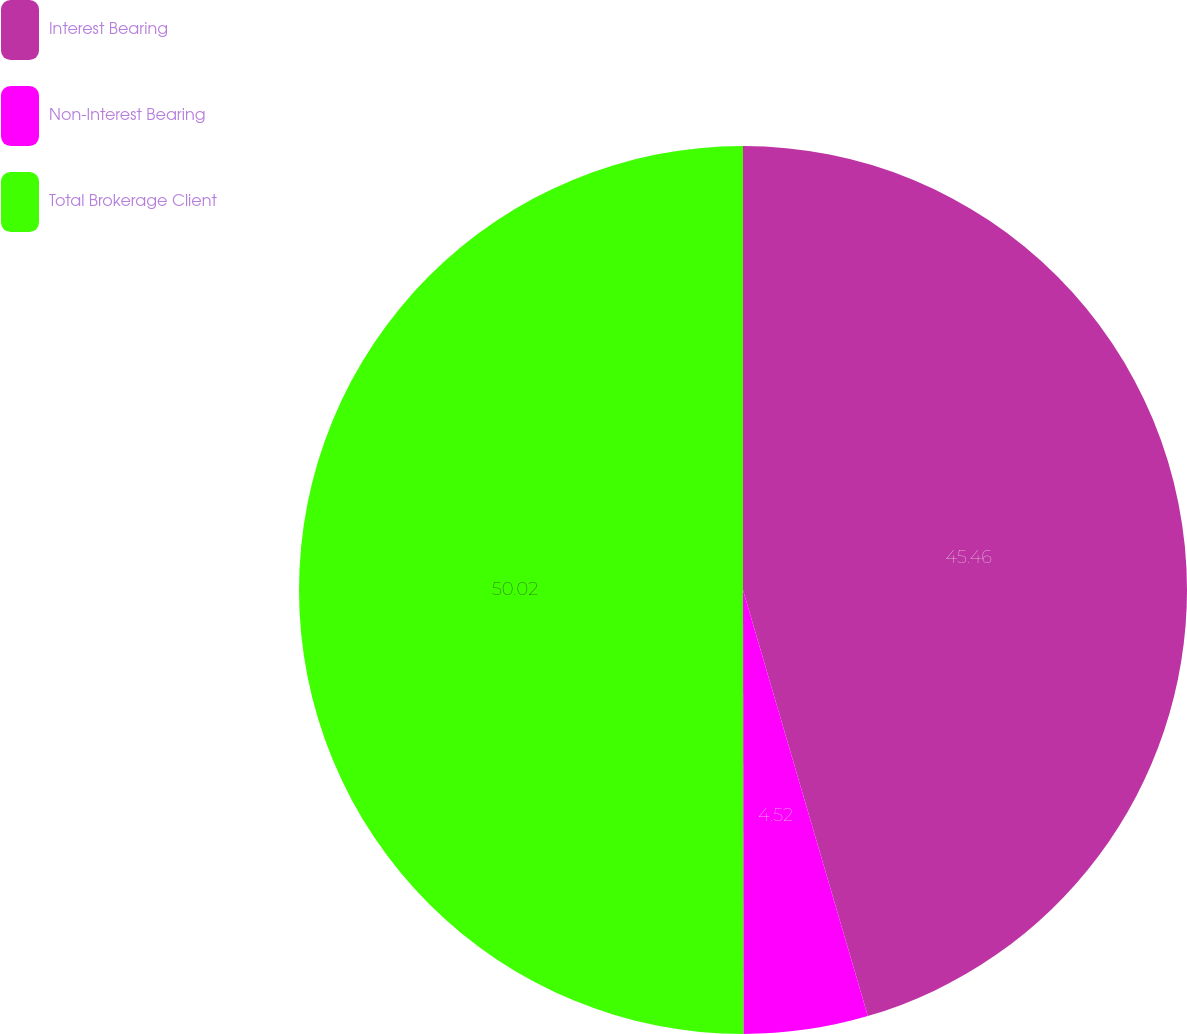Convert chart. <chart><loc_0><loc_0><loc_500><loc_500><pie_chart><fcel>Interest Bearing<fcel>Non-Interest Bearing<fcel>Total Brokerage Client<nl><fcel>45.46%<fcel>4.52%<fcel>50.01%<nl></chart> 